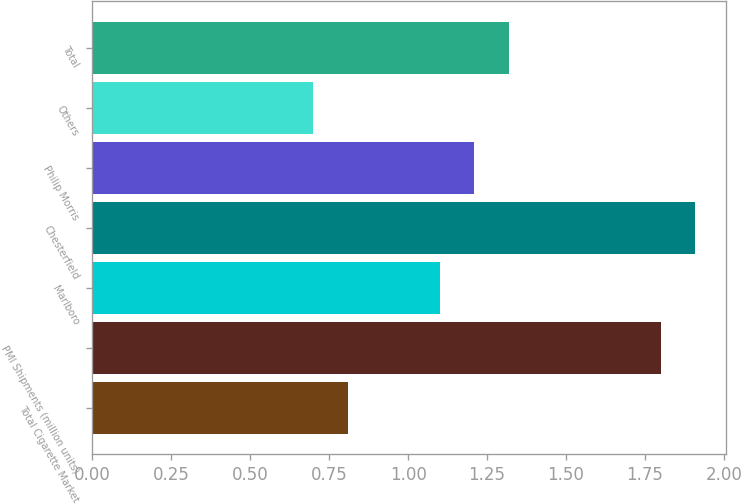Convert chart to OTSL. <chart><loc_0><loc_0><loc_500><loc_500><bar_chart><fcel>Total Cigarette Market<fcel>PMI Shipments (million units)<fcel>Marlboro<fcel>Chesterfield<fcel>Philip Morris<fcel>Others<fcel>Total<nl><fcel>0.81<fcel>1.8<fcel>1.1<fcel>1.91<fcel>1.21<fcel>0.7<fcel>1.32<nl></chart> 